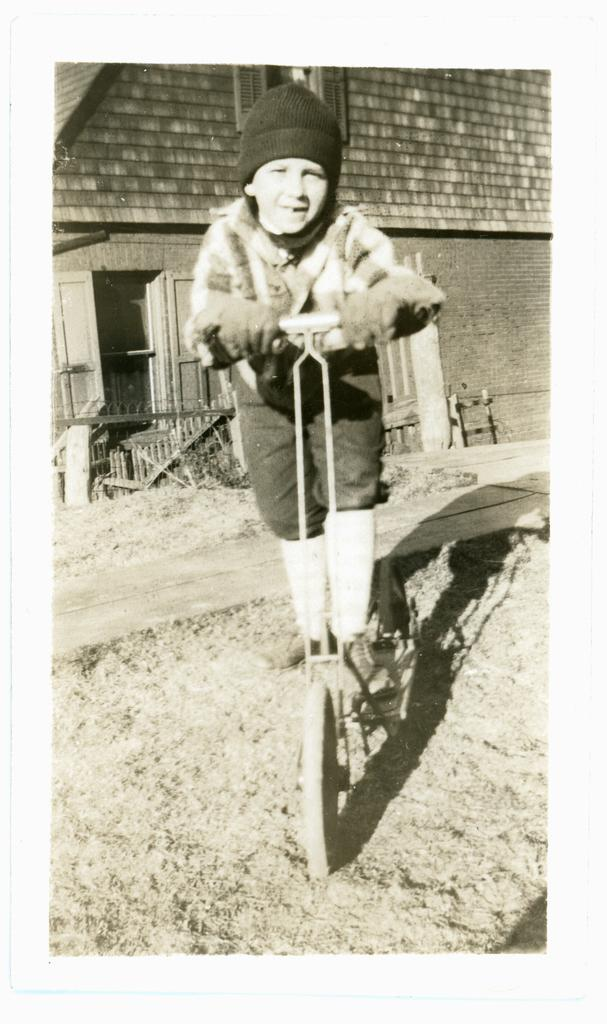What is the main subject in the foreground of the image? There is a boy in the foreground of the image. What is the boy doing in the image? The boy is riding a vehicle on the road. What can be seen in the background of the image? There is a building, a door, and a fence in the background of the image. Can you describe the time of day when the image was likely taken? The image was likely taken during the day, as there is no indication of darkness or artificial lighting. What type of berry is the boy holding in the image? There is no berry visible in the image; the boy is riding a vehicle on the road. What type of insurance policy does the building in the background offer? There is no information about insurance policies in the image; it only shows a building in the background. 